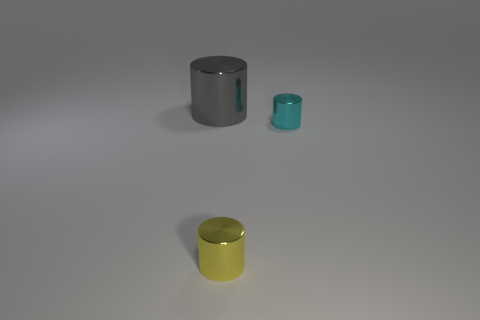What number of other shiny things have the same shape as the large object?
Give a very brief answer. 2. Are the thing that is on the right side of the small yellow cylinder and the yellow cylinder made of the same material?
Keep it short and to the point. Yes. How many cubes are tiny blue matte objects or yellow things?
Your response must be concise. 0. The tiny metallic thing that is in front of the tiny cylinder that is behind the tiny shiny object in front of the cyan object is what shape?
Make the answer very short. Cylinder. How many cyan things have the same size as the gray metal cylinder?
Ensure brevity in your answer.  0. There is a tiny thing that is in front of the small cyan metallic object; are there any tiny cyan cylinders behind it?
Make the answer very short. Yes. How many objects are either gray objects or shiny objects?
Ensure brevity in your answer.  3. What is the color of the small metallic cylinder on the right side of the small metal cylinder that is left of the small cylinder that is behind the small yellow cylinder?
Your response must be concise. Cyan. Does the yellow cylinder have the same size as the cyan metal cylinder?
Give a very brief answer. Yes. How many things are cylinders that are in front of the gray cylinder or tiny cylinders that are right of the yellow shiny cylinder?
Make the answer very short. 2. 